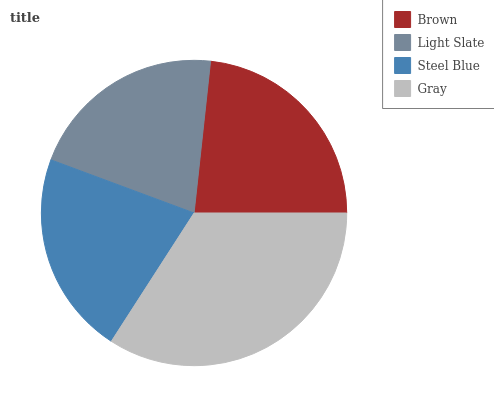Is Light Slate the minimum?
Answer yes or no. Yes. Is Gray the maximum?
Answer yes or no. Yes. Is Steel Blue the minimum?
Answer yes or no. No. Is Steel Blue the maximum?
Answer yes or no. No. Is Steel Blue greater than Light Slate?
Answer yes or no. Yes. Is Light Slate less than Steel Blue?
Answer yes or no. Yes. Is Light Slate greater than Steel Blue?
Answer yes or no. No. Is Steel Blue less than Light Slate?
Answer yes or no. No. Is Brown the high median?
Answer yes or no. Yes. Is Steel Blue the low median?
Answer yes or no. Yes. Is Light Slate the high median?
Answer yes or no. No. Is Light Slate the low median?
Answer yes or no. No. 